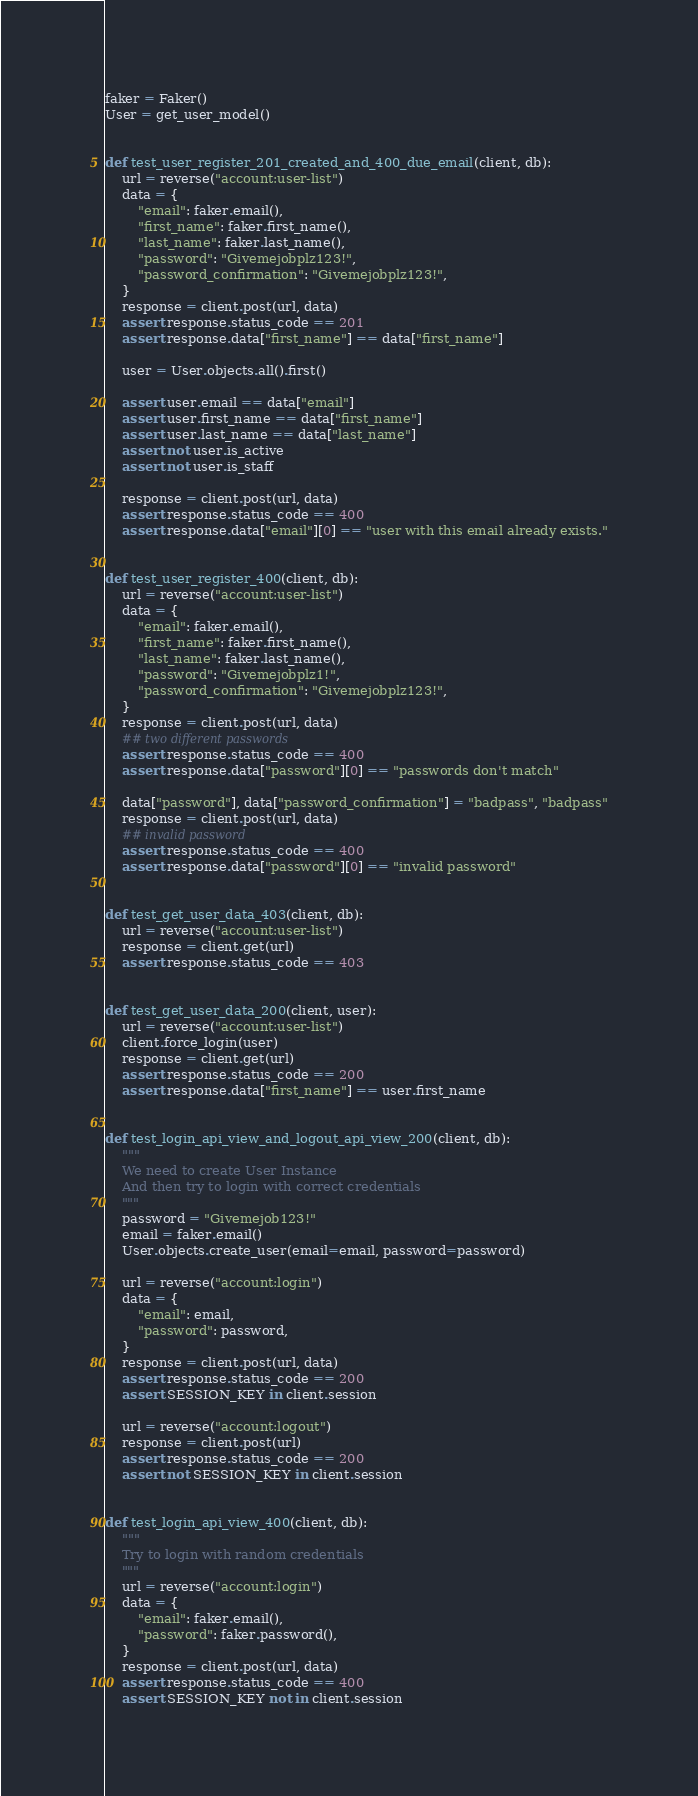<code> <loc_0><loc_0><loc_500><loc_500><_Python_>
faker = Faker()
User = get_user_model()


def test_user_register_201_created_and_400_due_email(client, db):
    url = reverse("account:user-list")
    data = {
        "email": faker.email(),
        "first_name": faker.first_name(),
        "last_name": faker.last_name(),
        "password": "Givemejobplz123!",
        "password_confirmation": "Givemejobplz123!",
    }
    response = client.post(url, data)
    assert response.status_code == 201
    assert response.data["first_name"] == data["first_name"]

    user = User.objects.all().first()

    assert user.email == data["email"]
    assert user.first_name == data["first_name"]
    assert user.last_name == data["last_name"]
    assert not user.is_active
    assert not user.is_staff

    response = client.post(url, data)
    assert response.status_code == 400
    assert response.data["email"][0] == "user with this email already exists."


def test_user_register_400(client, db):
    url = reverse("account:user-list")
    data = {
        "email": faker.email(),
        "first_name": faker.first_name(),
        "last_name": faker.last_name(),
        "password": "Givemejobplz1!",
        "password_confirmation": "Givemejobplz123!",
    }
    response = client.post(url, data)
    ## two different passwords
    assert response.status_code == 400
    assert response.data["password"][0] == "passwords don't match"

    data["password"], data["password_confirmation"] = "badpass", "badpass"
    response = client.post(url, data)
    ## invalid password
    assert response.status_code == 400
    assert response.data["password"][0] == "invalid password"


def test_get_user_data_403(client, db):
    url = reverse("account:user-list")
    response = client.get(url)
    assert response.status_code == 403


def test_get_user_data_200(client, user):
    url = reverse("account:user-list")
    client.force_login(user)
    response = client.get(url)
    assert response.status_code == 200
    assert response.data["first_name"] == user.first_name


def test_login_api_view_and_logout_api_view_200(client, db):
    """
    We need to create User Instance
    And then try to login with correct credentials
    """
    password = "Givemejob123!"
    email = faker.email()
    User.objects.create_user(email=email, password=password)

    url = reverse("account:login")
    data = {
        "email": email,
        "password": password,
    }
    response = client.post(url, data)
    assert response.status_code == 200
    assert SESSION_KEY in client.session

    url = reverse("account:logout")
    response = client.post(url)
    assert response.status_code == 200
    assert not SESSION_KEY in client.session


def test_login_api_view_400(client, db):
    """
    Try to login with random credentials
    """
    url = reverse("account:login")
    data = {
        "email": faker.email(),
        "password": faker.password(),
    }
    response = client.post(url, data)
    assert response.status_code == 400
    assert SESSION_KEY not in client.session
</code> 